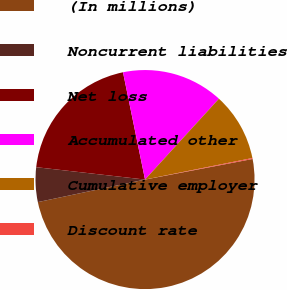Convert chart to OTSL. <chart><loc_0><loc_0><loc_500><loc_500><pie_chart><fcel>(In millions)<fcel>Noncurrent liabilities<fcel>Net loss<fcel>Accumulated other<fcel>Cumulative employer<fcel>Discount rate<nl><fcel>49.71%<fcel>5.1%<fcel>19.97%<fcel>15.01%<fcel>10.06%<fcel>0.14%<nl></chart> 